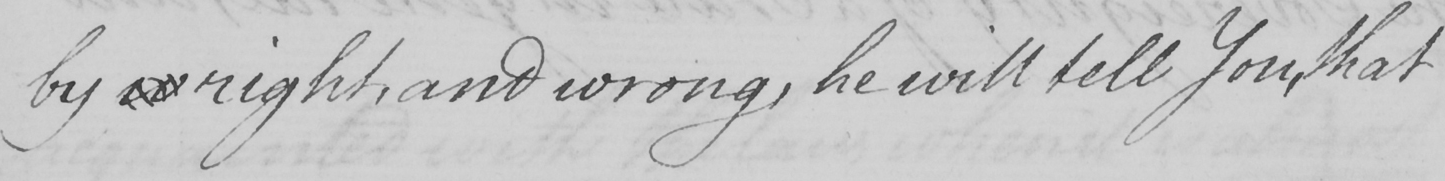What does this handwritten line say? by w right, and wrong, he will tell You, that 